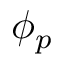Convert formula to latex. <formula><loc_0><loc_0><loc_500><loc_500>\phi _ { p }</formula> 